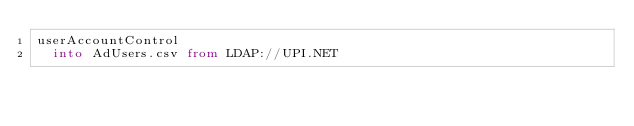Convert code to text. <code><loc_0><loc_0><loc_500><loc_500><_SQL_>userAccountControl
  into AdUsers.csv from LDAP://UPI.NET
</code> 